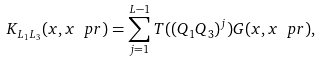<formula> <loc_0><loc_0><loc_500><loc_500>K _ { L _ { 1 } L _ { 3 } } ( x , x ^ { \ } p r ) = \sum _ { j = 1 } ^ { L - 1 } T ( ( Q _ { 1 } Q _ { 3 } ) ^ { j } ) G ( x , x ^ { \ } p r ) ,</formula> 